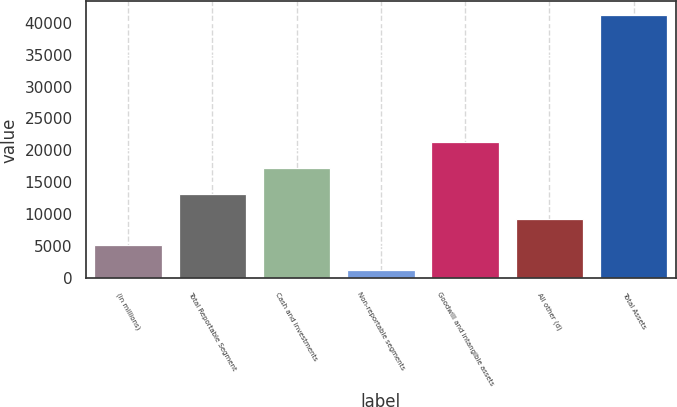Convert chart. <chart><loc_0><loc_0><loc_500><loc_500><bar_chart><fcel>(in millions)<fcel>Total Reportable Segment<fcel>Cash and investments<fcel>Non-reportable segments<fcel>Goodwill and intangible assets<fcel>All other (d)<fcel>Total Assets<nl><fcel>5265<fcel>13261<fcel>17259<fcel>1267<fcel>21257<fcel>9263<fcel>41247<nl></chart> 